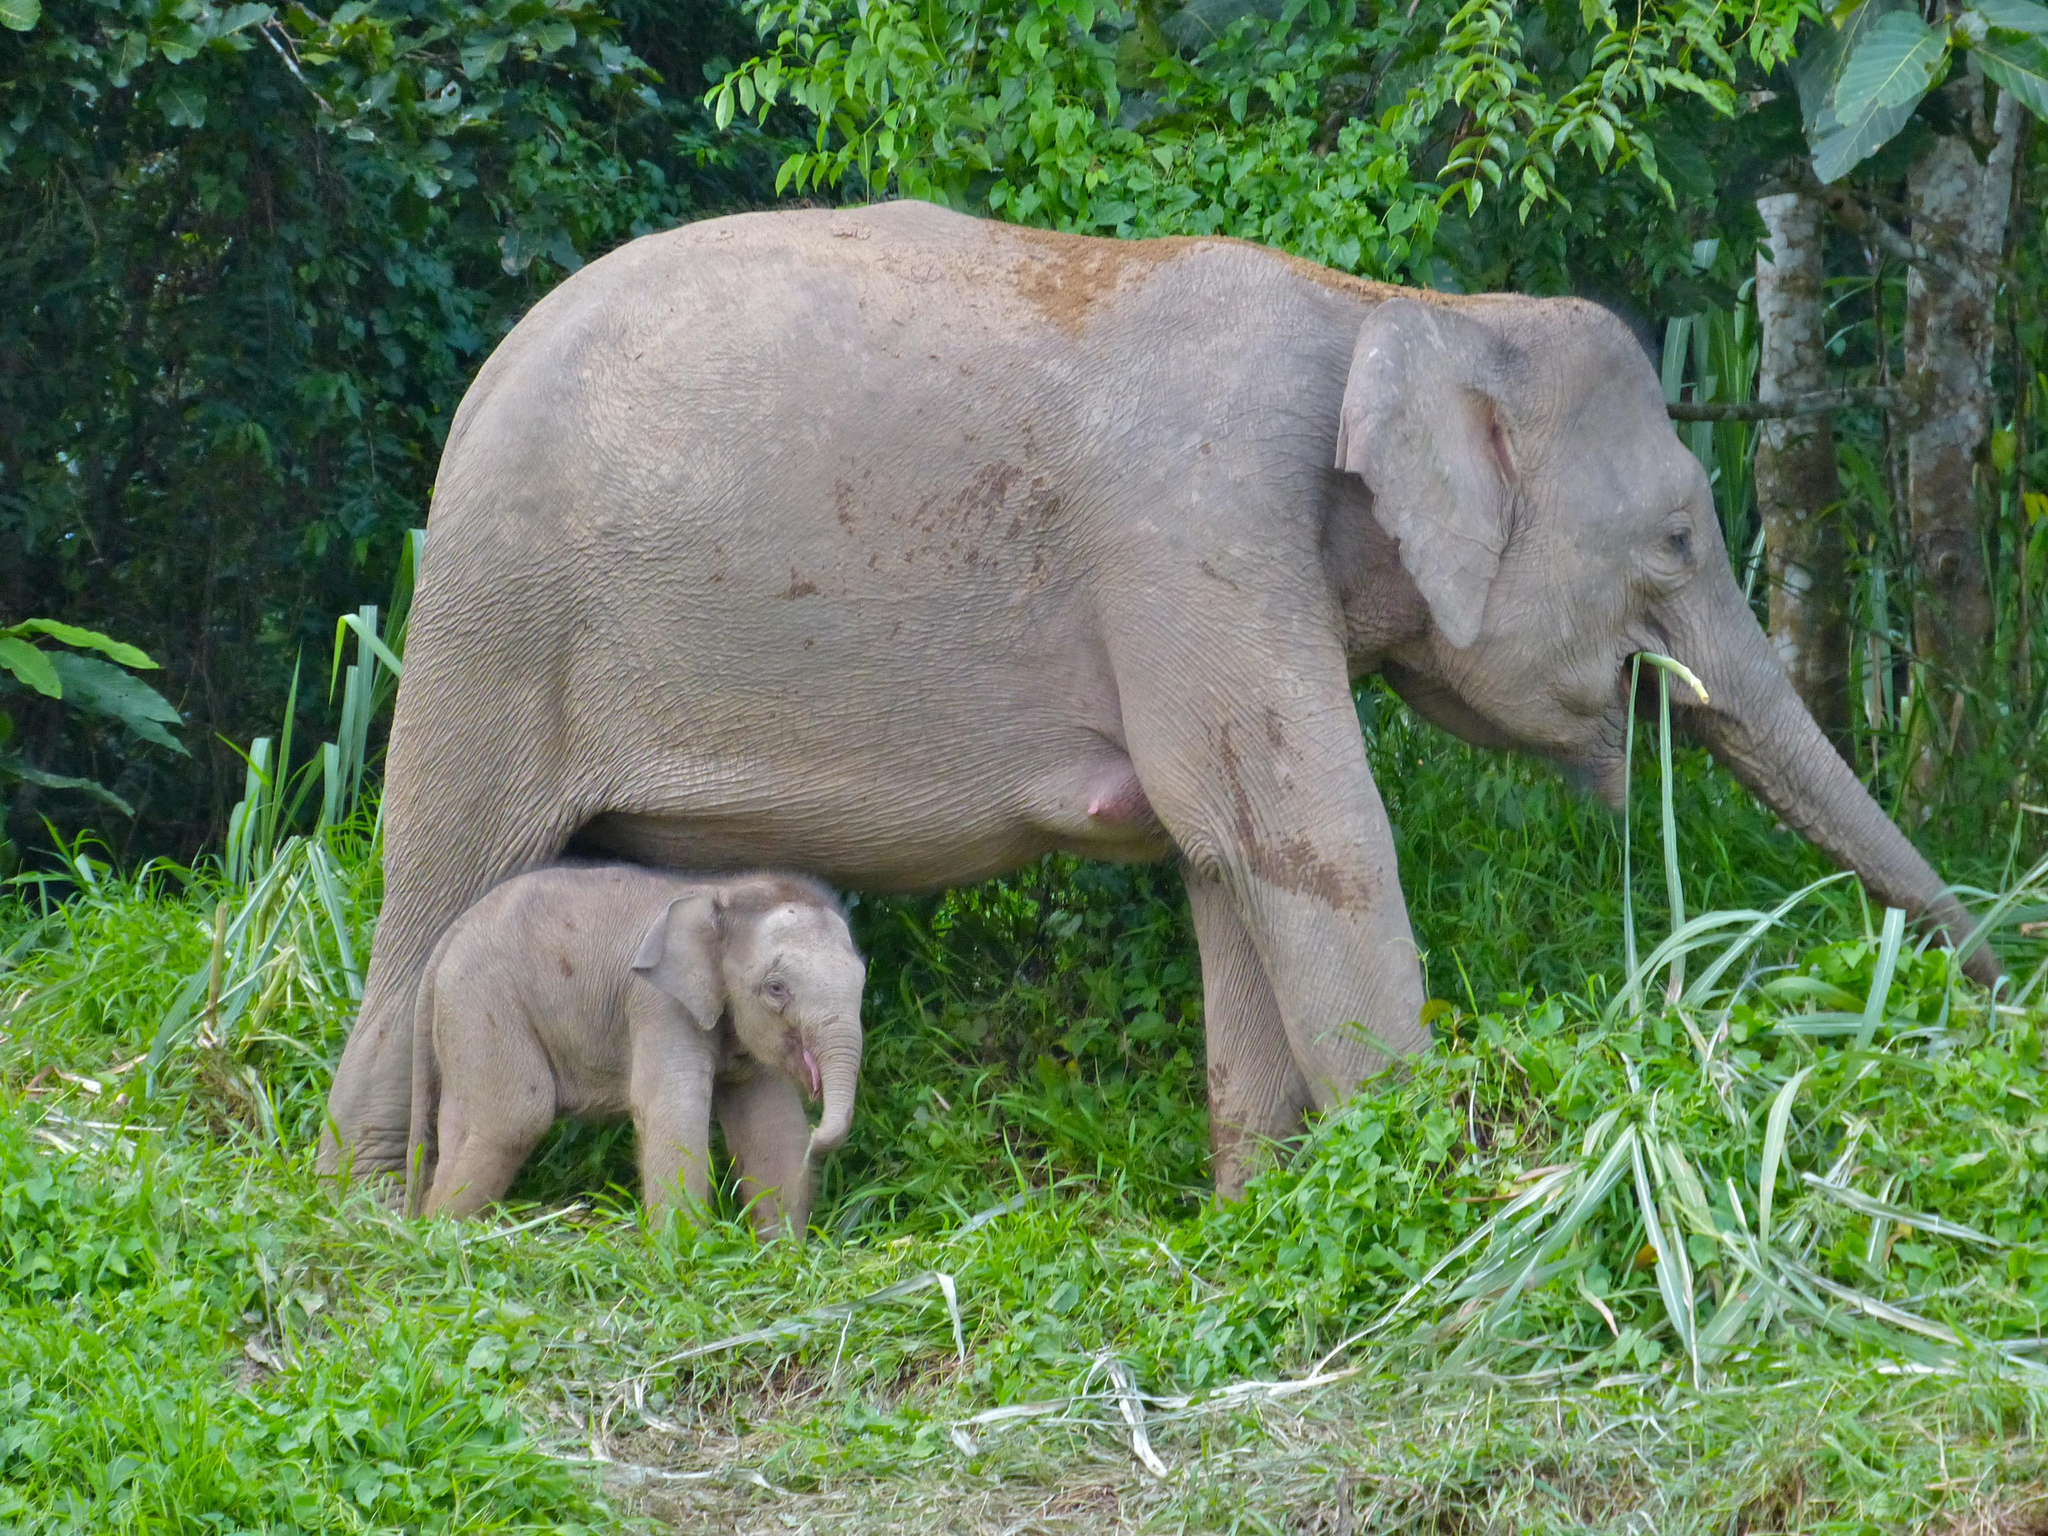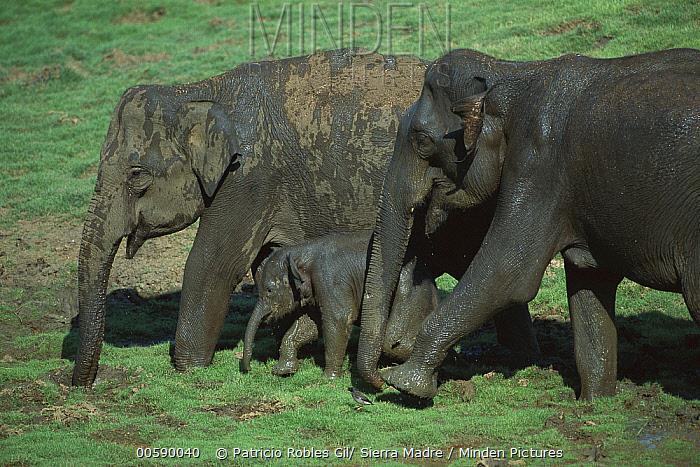The first image is the image on the left, the second image is the image on the right. Analyze the images presented: Is the assertion "There are two animals in the grassy area in the image on the right." valid? Answer yes or no. No. 